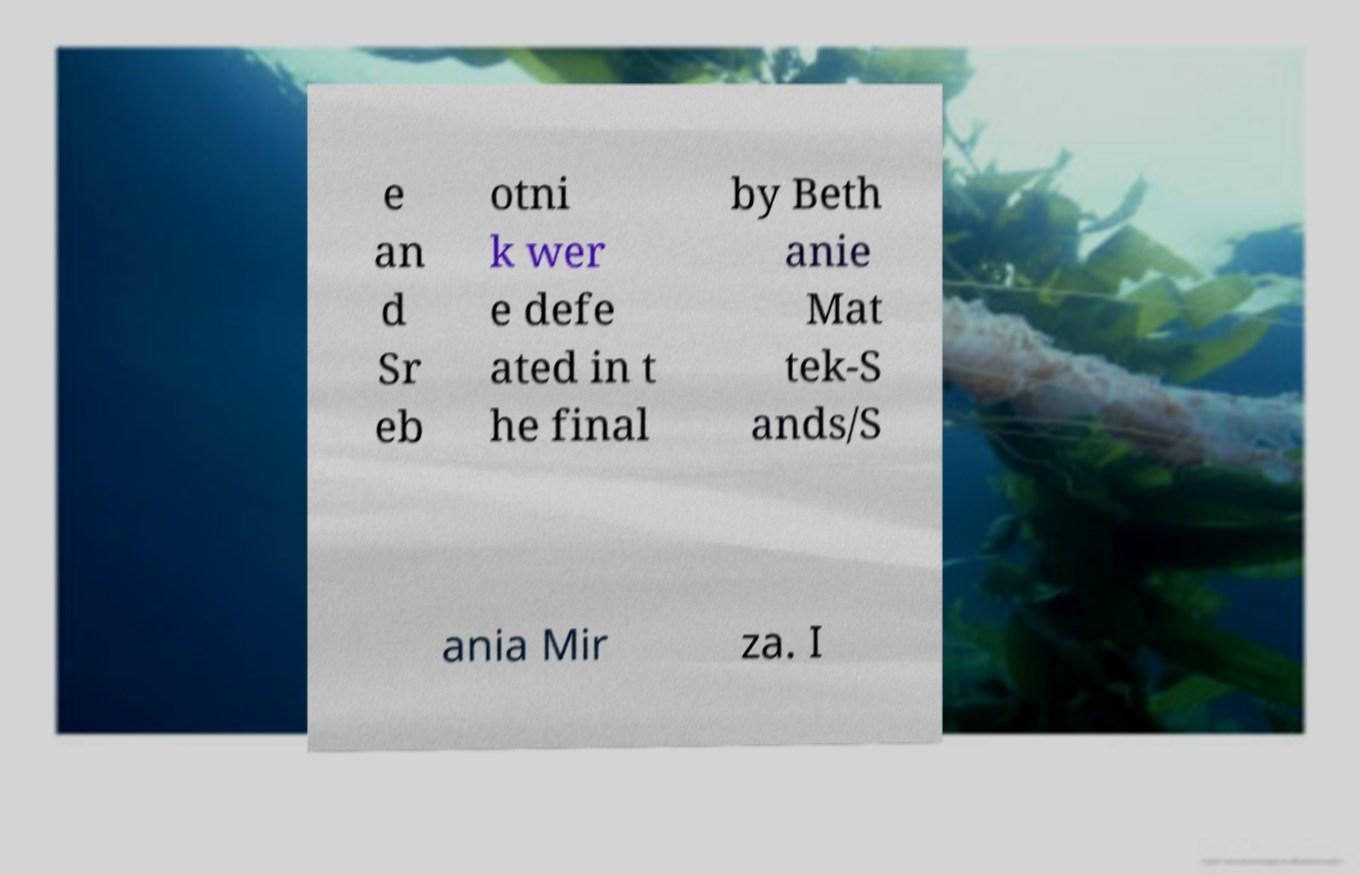What messages or text are displayed in this image? I need them in a readable, typed format. e an d Sr eb otni k wer e defe ated in t he final by Beth anie Mat tek-S ands/S ania Mir za. I 